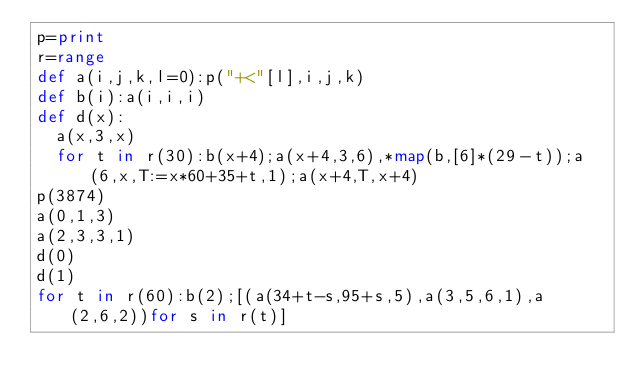Convert code to text. <code><loc_0><loc_0><loc_500><loc_500><_Python_>p=print
r=range
def a(i,j,k,l=0):p("+<"[l],i,j,k)
def b(i):a(i,i,i)
def d(x):
	a(x,3,x)
	for t in r(30):b(x+4);a(x+4,3,6),*map(b,[6]*(29-t));a(6,x,T:=x*60+35+t,1);a(x+4,T,x+4)
p(3874)
a(0,1,3)
a(2,3,3,1)
d(0)
d(1)
for t in r(60):b(2);[(a(34+t-s,95+s,5),a(3,5,6,1),a(2,6,2))for s in r(t)]</code> 